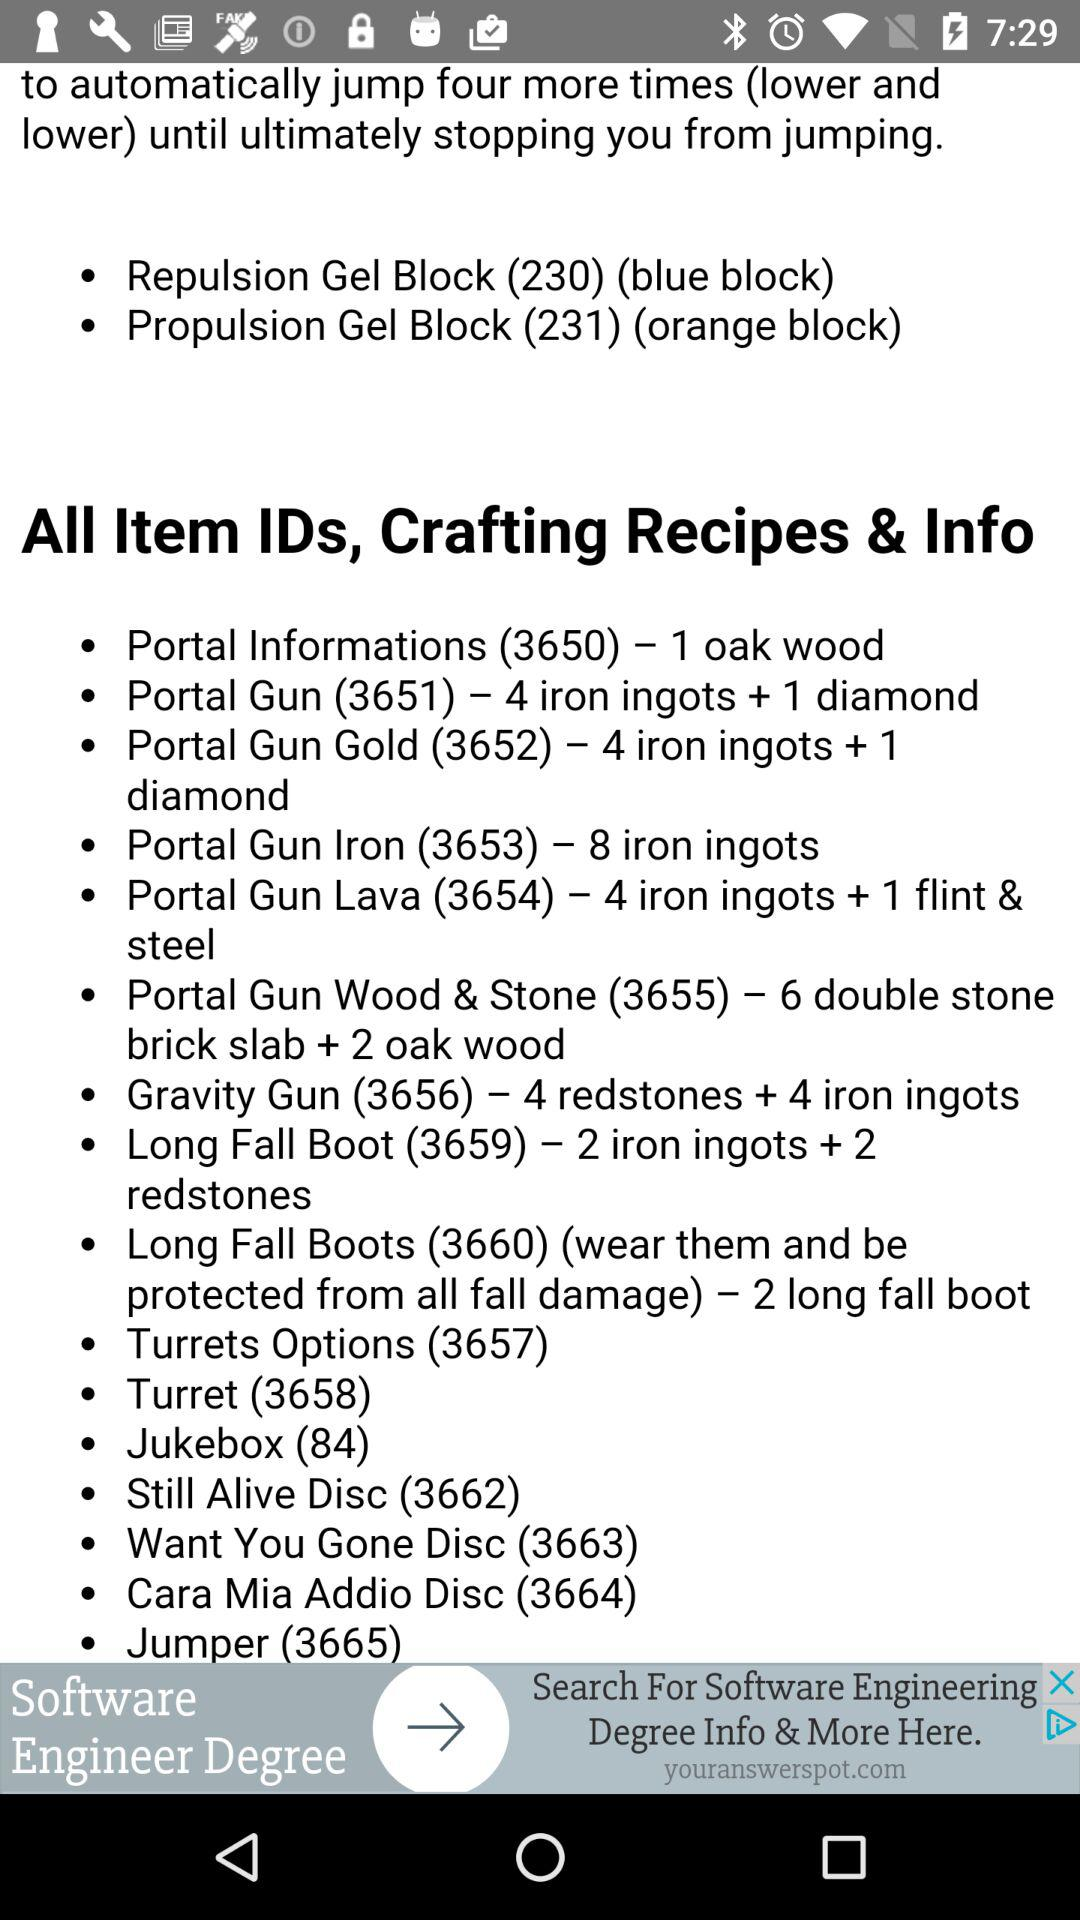How many more iron ingots are in the Portal Gun Iron recipe than in the Portal Gun Lava recipe?
Answer the question using a single word or phrase. 4 